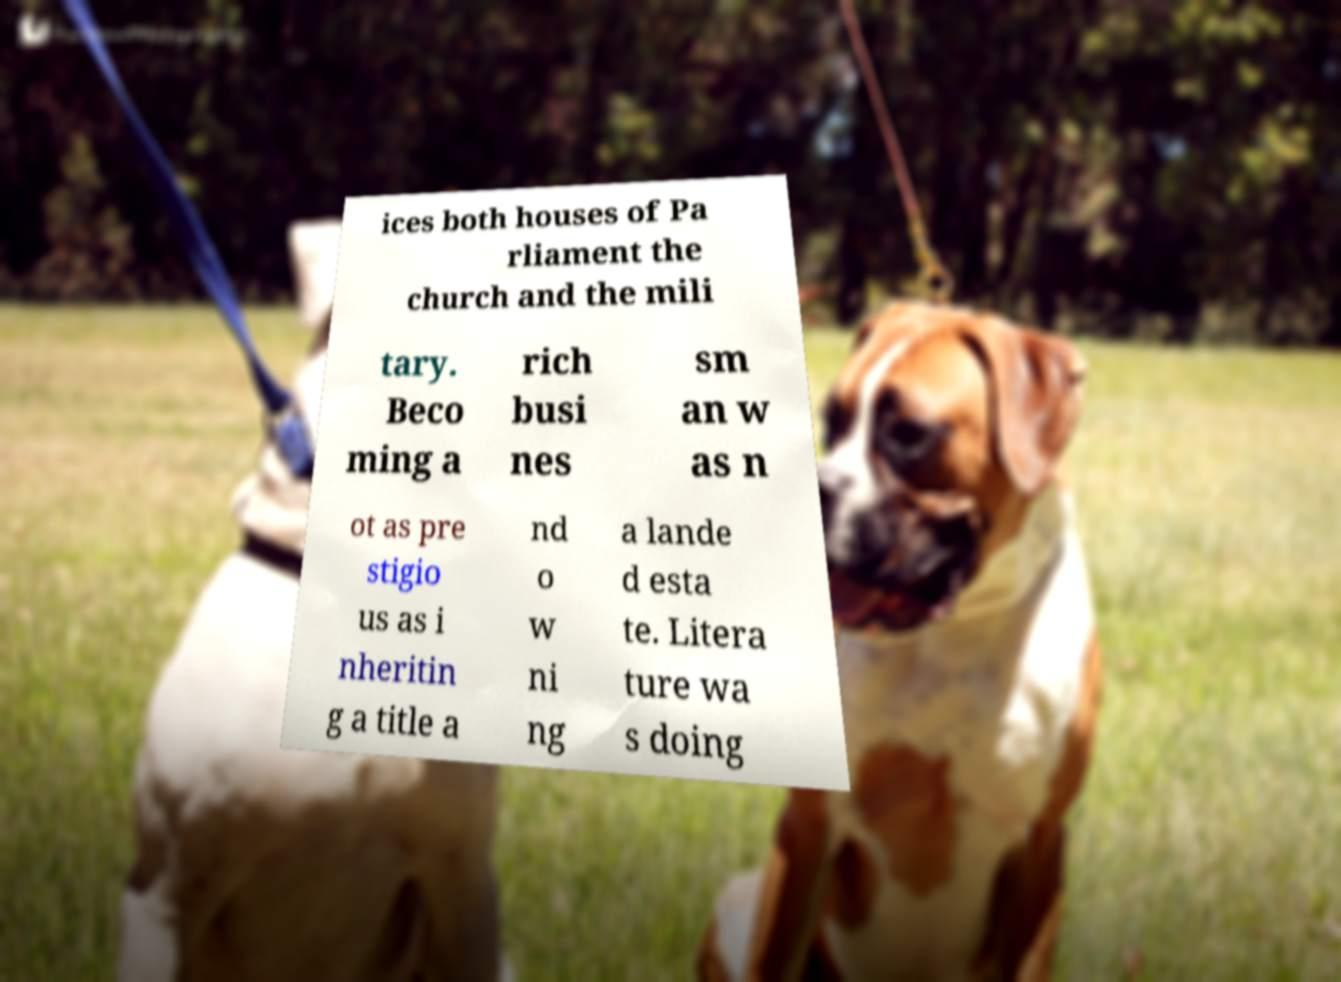What messages or text are displayed in this image? I need them in a readable, typed format. ices both houses of Pa rliament the church and the mili tary. Beco ming a rich busi nes sm an w as n ot as pre stigio us as i nheritin g a title a nd o w ni ng a lande d esta te. Litera ture wa s doing 